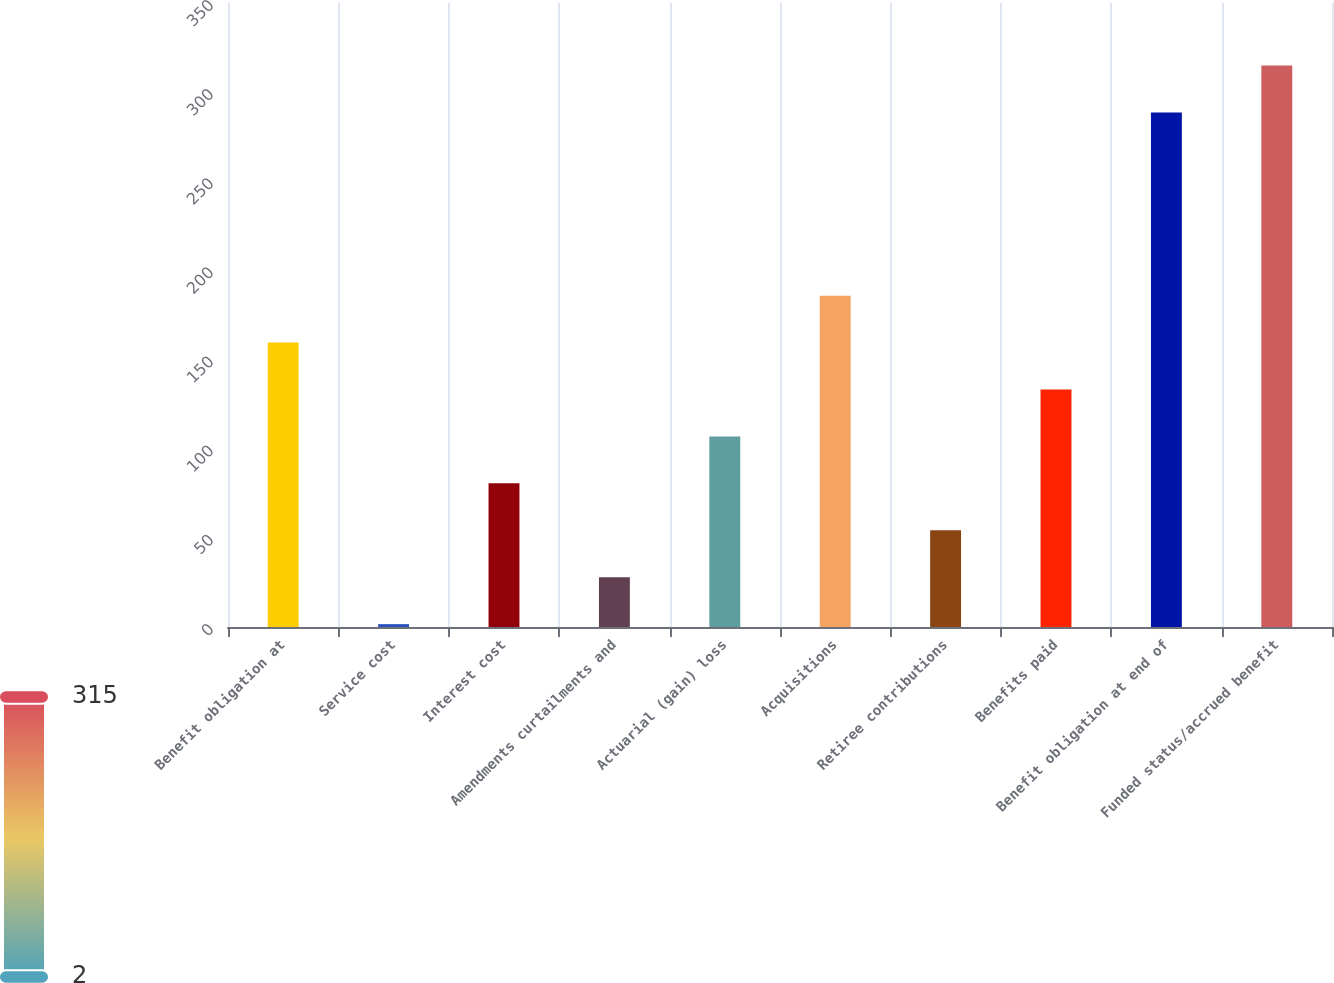Convert chart. <chart><loc_0><loc_0><loc_500><loc_500><bar_chart><fcel>Benefit obligation at<fcel>Service cost<fcel>Interest cost<fcel>Amendments curtailments and<fcel>Actuarial (gain) loss<fcel>Acquisitions<fcel>Retiree contributions<fcel>Benefits paid<fcel>Benefit obligation at end of<fcel>Funded status/accrued benefit<nl><fcel>159.52<fcel>1.6<fcel>80.56<fcel>27.92<fcel>106.88<fcel>185.84<fcel>54.24<fcel>133.2<fcel>288.62<fcel>314.94<nl></chart> 